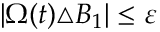Convert formula to latex. <formula><loc_0><loc_0><loc_500><loc_500>\begin{array} { r } { | \Omega ( t ) \triangle B _ { 1 } | \leq \varepsilon } \end{array}</formula> 